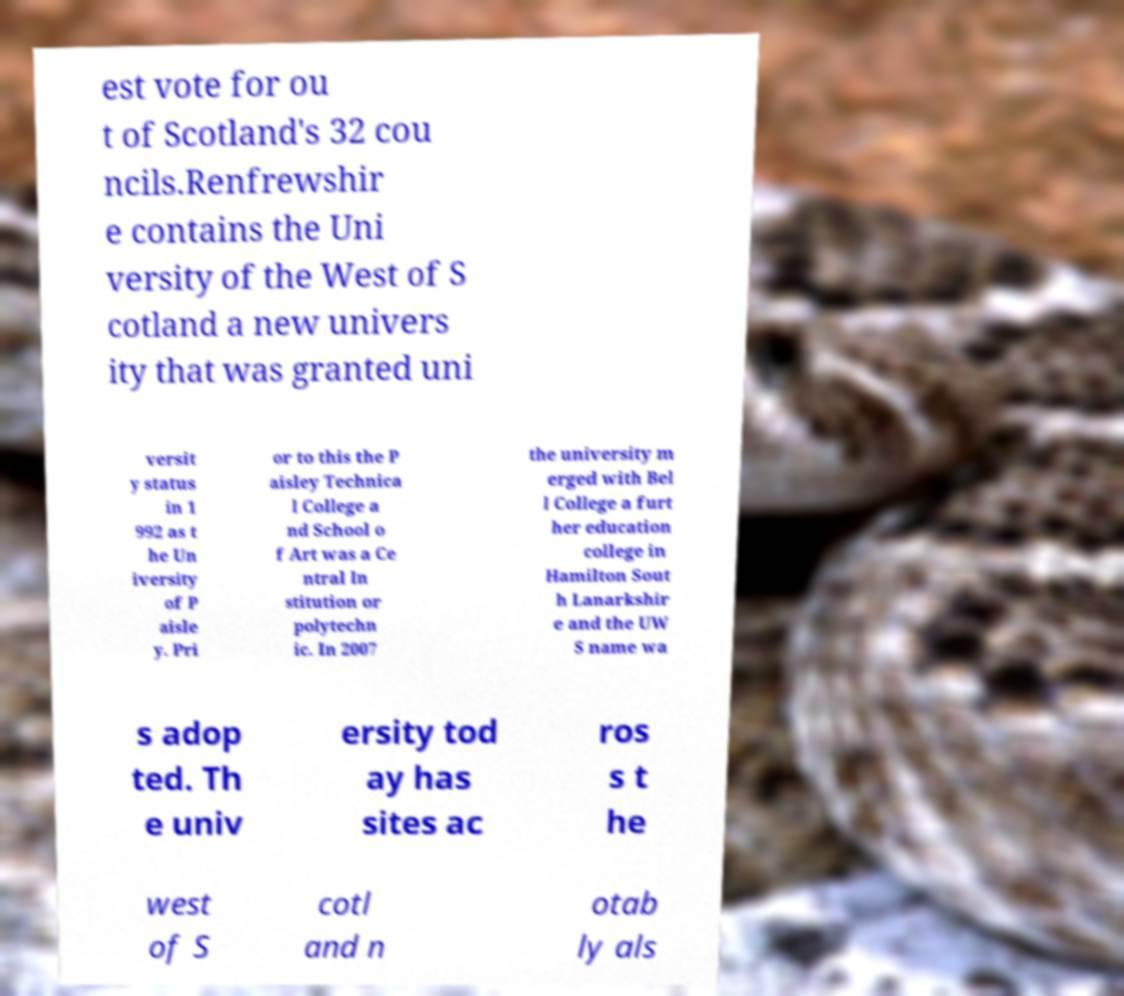Can you read and provide the text displayed in the image?This photo seems to have some interesting text. Can you extract and type it out for me? est vote for ou t of Scotland's 32 cou ncils.Renfrewshir e contains the Uni versity of the West of S cotland a new univers ity that was granted uni versit y status in 1 992 as t he Un iversity of P aisle y. Pri or to this the P aisley Technica l College a nd School o f Art was a Ce ntral In stitution or polytechn ic. In 2007 the university m erged with Bel l College a furt her education college in Hamilton Sout h Lanarkshir e and the UW S name wa s adop ted. Th e univ ersity tod ay has sites ac ros s t he west of S cotl and n otab ly als 